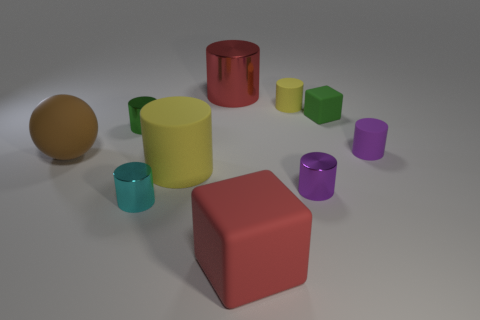Subtract 5 cylinders. How many cylinders are left? 2 Subtract all green cylinders. How many cylinders are left? 6 Subtract all green blocks. How many blocks are left? 1 Subtract 0 gray cylinders. How many objects are left? 10 Subtract all balls. How many objects are left? 9 Subtract all brown blocks. Subtract all brown balls. How many blocks are left? 2 Subtract all blue cylinders. How many gray blocks are left? 0 Subtract all tiny cyan rubber blocks. Subtract all big red rubber things. How many objects are left? 9 Add 3 tiny matte cylinders. How many tiny matte cylinders are left? 5 Add 5 big shiny cubes. How many big shiny cubes exist? 5 